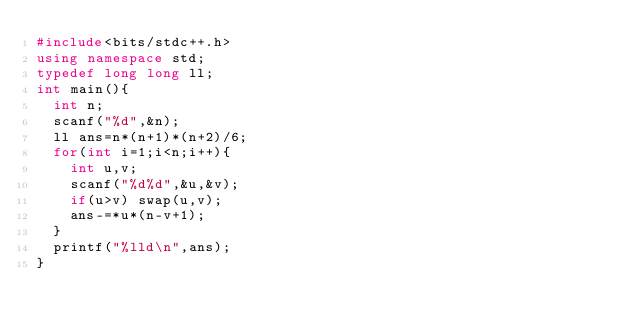Convert code to text. <code><loc_0><loc_0><loc_500><loc_500><_C++_>#include<bits/stdc++.h>
using namespace std;
typedef long long ll;
int main(){
	int n;
	scanf("%d",&n);
	ll ans=n*(n+1)*(n+2)/6;
	for(int i=1;i<n;i++){
		int u,v;
		scanf("%d%d",&u,&v);
		if(u>v) swap(u,v);
		ans-=*u*(n-v+1); 
	}
	printf("%lld\n",ans); 
}</code> 